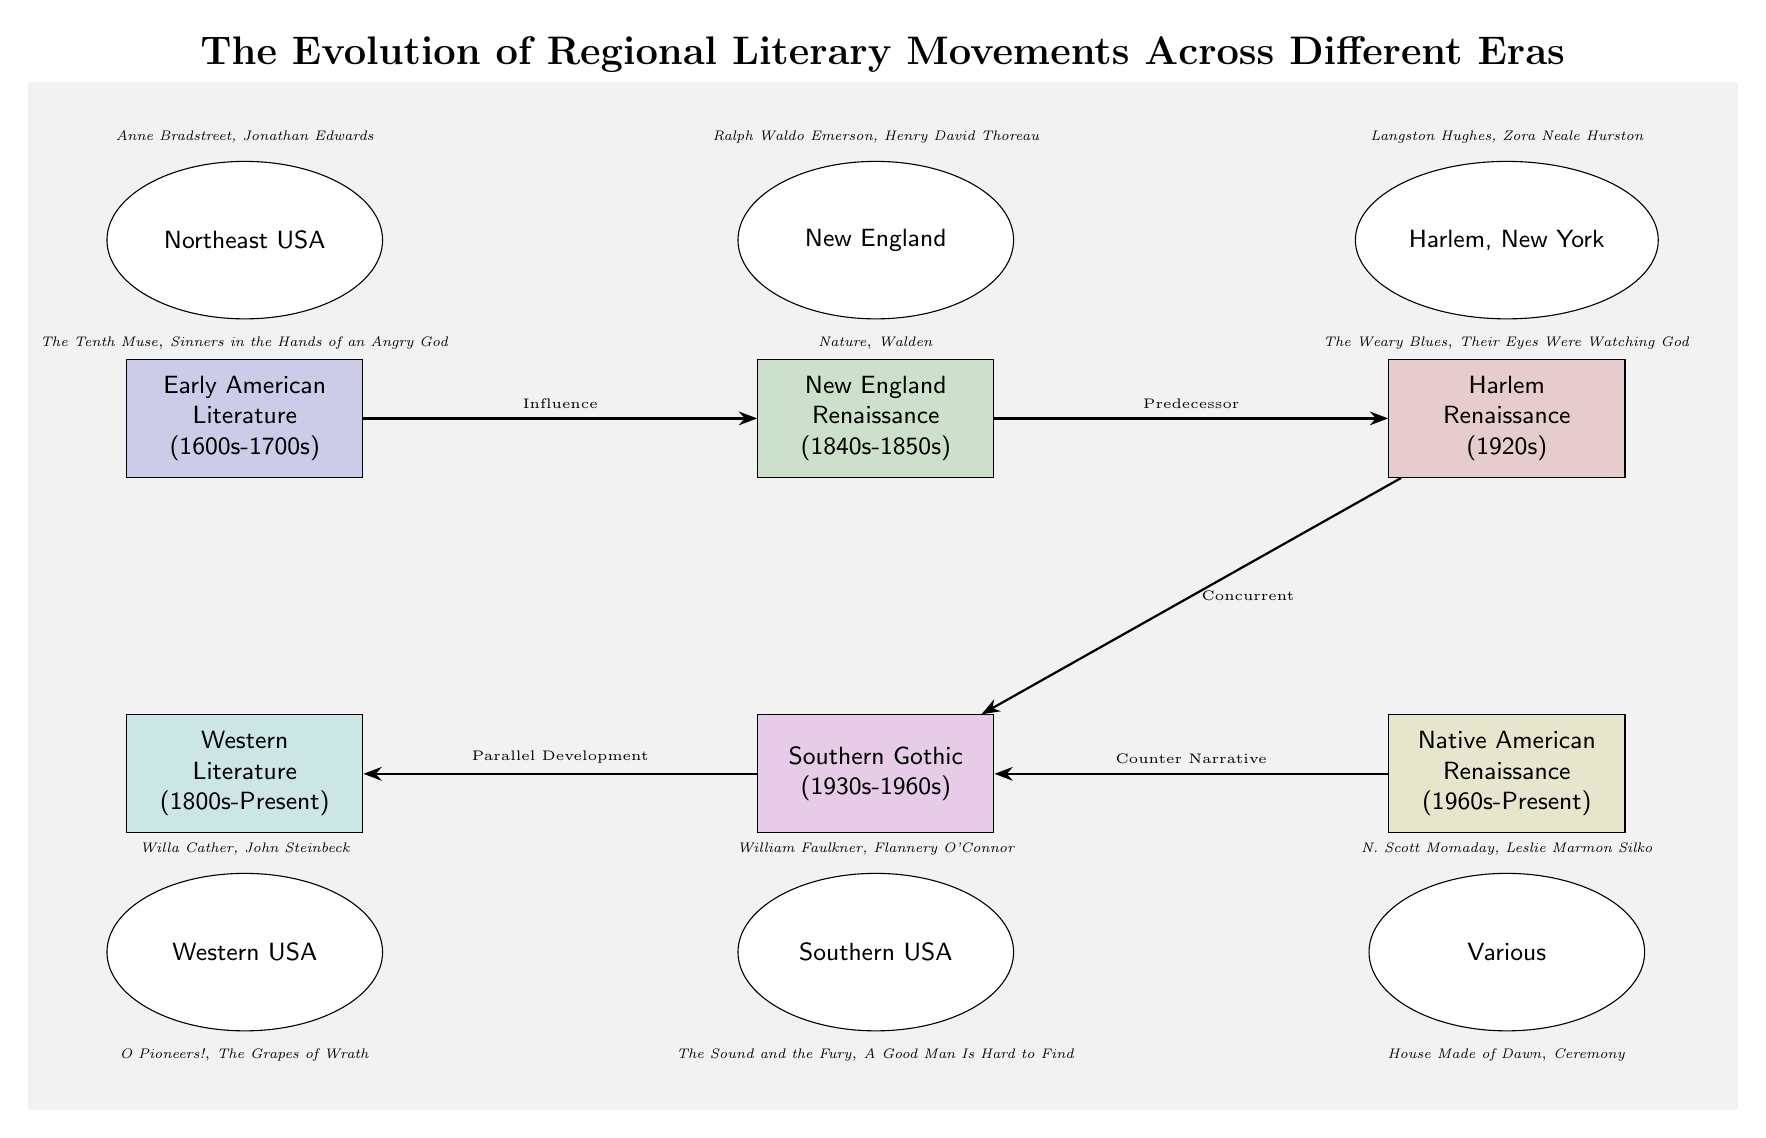What is the era of the Harlem Renaissance? The diagram specifies that the Harlem Renaissance occurs in the 1920s, as indicated in the corresponding node labeled "Harlem Renaissance (1920s)."
Answer: 1920s Who is a key author from the Southern Gothic movement? The diagram presents key authors associated with the Southern Gothic movement, specifically William Faulkner and Flannery O'Connor, as shown in the Southern Gothic node.
Answer: William Faulkner, Flannery O'Connor What is the relationship between the New England Renaissance and the Harlem Renaissance? The diagram illustrates that the New England Renaissance is a predecessor to the Harlem Renaissance, indicated by the arrow labeled "Predecessor" between the two nodes.
Answer: Predecessor Which region is represented by the authors Anne Bradstreet and Jonathan Edwards? According to the diagram, the authors Anne Bradstreet and Jonathan Edwards are situated in the Northeast USA, established in the corresponding node above the Early American Literature era.
Answer: Northeast USA How many literary movements are represented in the diagram? The diagram lists six distinct literary movements, which can be counted from the nodes labeled Early American Literature, New England Renaissance, Harlem Renaissance, Southern Gothic, Western Literature, and Native American Renaissance.
Answer: 6 Which movement has a concurrent relationship with the Harlem Renaissance? From the diagram, it is depicted that the Harlem Renaissance has a concurrent relationship with the Southern Gothic movement, as noted by the arrow indicating "Concurrent."
Answer: Southern Gothic What works are associated with Willa Cather? The diagram identifies the works associated with Willa Cather as "O Pioneers!" indicated directly below her author name in the Western Literature node.
Answer: O Pioneers! What is the timeline span of the Native American Renaissance? The diagram specifies that the Native American Renaissance spans from the 1960s to the present, as detailed in its labeled node.
Answer: 1960s-Present Which two authors are noted for the Native American Renaissance? The diagram lists N. Scott Momaday and Leslie Marmon Silko as the two key authors relevant to the Native American Renaissance in the corresponding region node.
Answer: N. Scott Momaday, Leslie Marmon Silko 